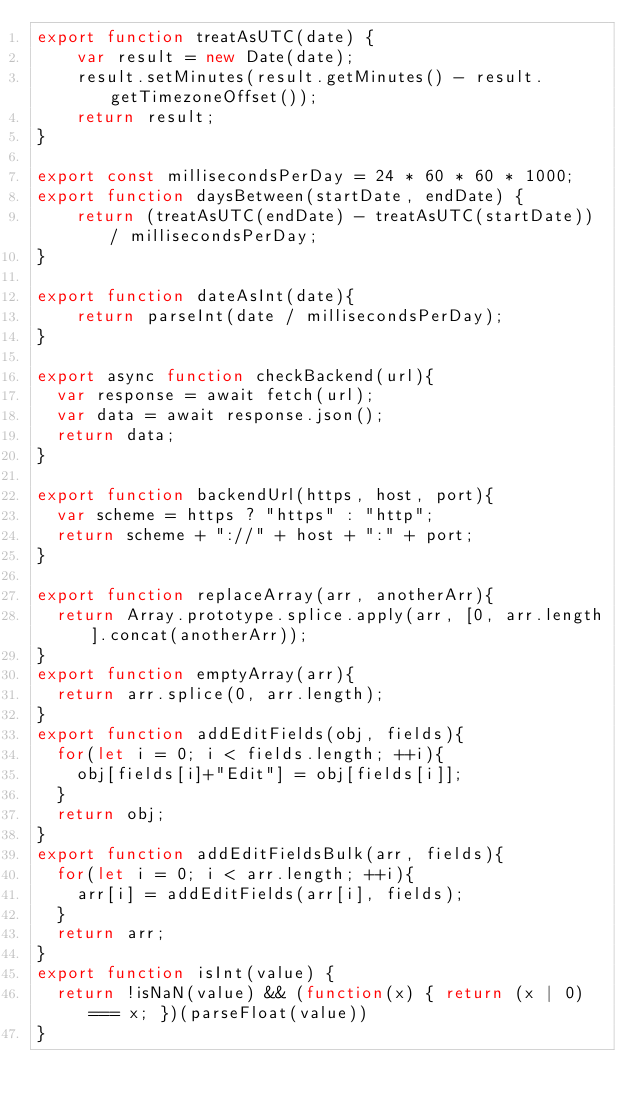<code> <loc_0><loc_0><loc_500><loc_500><_JavaScript_>export function treatAsUTC(date) {
    var result = new Date(date);
    result.setMinutes(result.getMinutes() - result.getTimezoneOffset());
    return result;
}

export const millisecondsPerDay = 24 * 60 * 60 * 1000;
export function daysBetween(startDate, endDate) {
    return (treatAsUTC(endDate) - treatAsUTC(startDate)) / millisecondsPerDay;
}

export function dateAsInt(date){
    return parseInt(date / millisecondsPerDay);
}

export async function checkBackend(url){
	var response = await fetch(url);
	var data = await response.json();
	return data;
}

export function backendUrl(https, host, port){
	var scheme = https ? "https" : "http";
	return scheme + "://" + host + ":" + port;
}

export function replaceArray(arr, anotherArr){
	return Array.prototype.splice.apply(arr, [0, arr.length].concat(anotherArr));
}
export function emptyArray(arr){
	return arr.splice(0, arr.length);
}
export function addEditFields(obj, fields){
	for(let i = 0; i < fields.length; ++i){
		obj[fields[i]+"Edit"] = obj[fields[i]];
	}
	return obj;
}
export function addEditFieldsBulk(arr, fields){
	for(let i = 0; i < arr.length; ++i){
		arr[i] = addEditFields(arr[i], fields);
	}
	return arr;
}
export function isInt(value) {
	return !isNaN(value) && (function(x) { return (x | 0) === x; })(parseFloat(value))
}</code> 